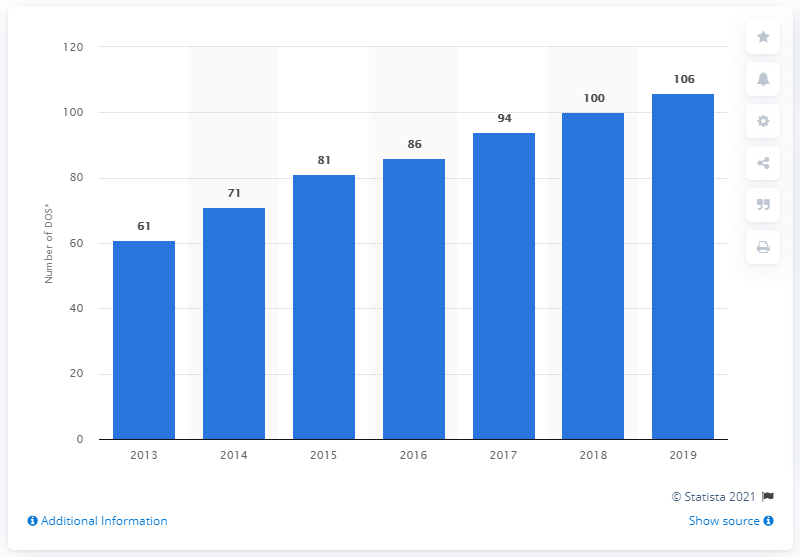Outline some significant characteristics in this image. In 2019, Brunello Cucinelli had a total of 106 monobrand retail stores. 